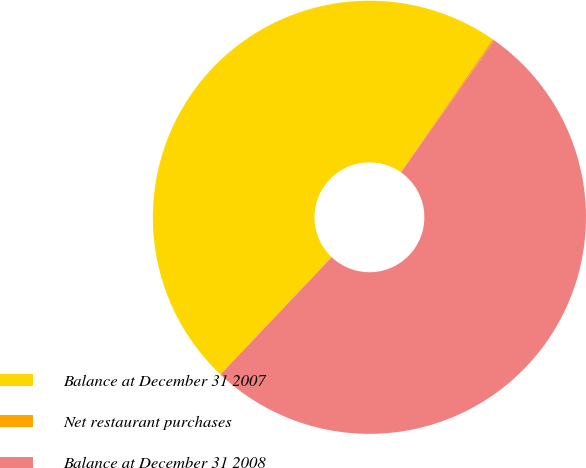Convert chart. <chart><loc_0><loc_0><loc_500><loc_500><pie_chart><fcel>Balance at December 31 2007<fcel>Net restaurant purchases<fcel>Balance at December 31 2008<nl><fcel>47.56%<fcel>0.13%<fcel>52.31%<nl></chart> 